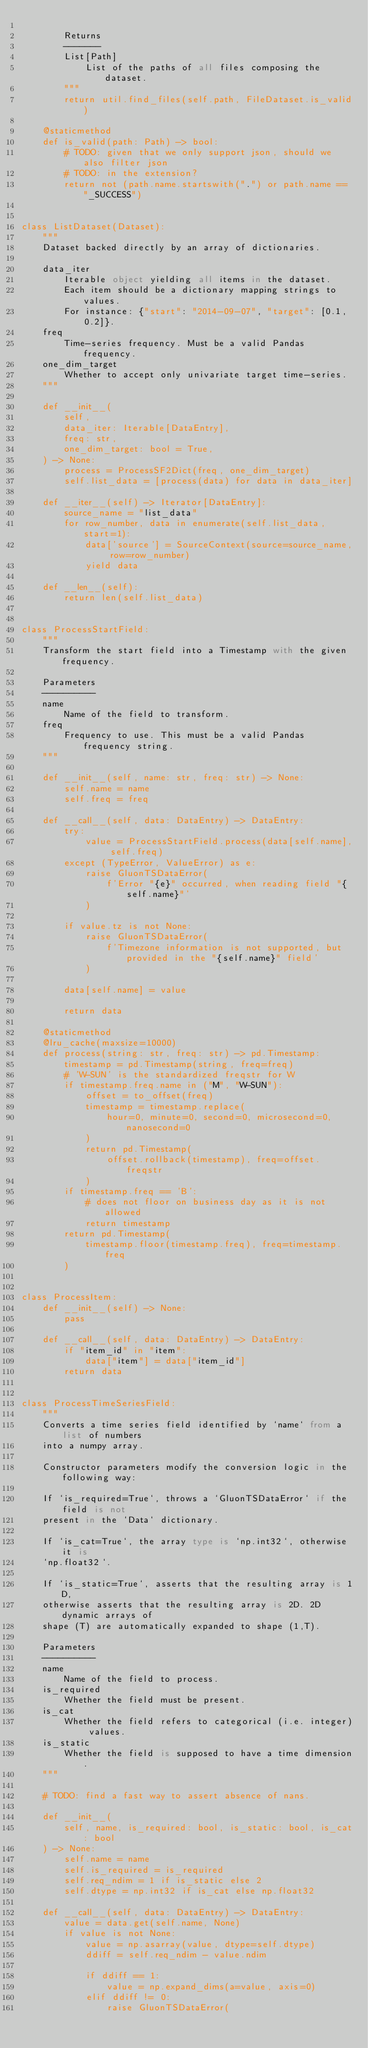<code> <loc_0><loc_0><loc_500><loc_500><_Python_>
        Returns
        -------
        List[Path]
            List of the paths of all files composing the dataset.
        """
        return util.find_files(self.path, FileDataset.is_valid)

    @staticmethod
    def is_valid(path: Path) -> bool:
        # TODO: given that we only support json, should we also filter json
        # TODO: in the extension?
        return not (path.name.startswith(".") or path.name == "_SUCCESS")


class ListDataset(Dataset):
    """
    Dataset backed directly by an array of dictionaries.

    data_iter
        Iterable object yielding all items in the dataset.
        Each item should be a dictionary mapping strings to values.
        For instance: {"start": "2014-09-07", "target": [0.1, 0.2]}.
    freq
        Time-series frequency. Must be a valid Pandas frequency.
    one_dim_target
        Whether to accept only univariate target time-series.
    """

    def __init__(
        self,
        data_iter: Iterable[DataEntry],
        freq: str,
        one_dim_target: bool = True,
    ) -> None:
        process = ProcessSF2Dict(freq, one_dim_target)
        self.list_data = [process(data) for data in data_iter]

    def __iter__(self) -> Iterator[DataEntry]:
        source_name = "list_data"
        for row_number, data in enumerate(self.list_data, start=1):
            data['source'] = SourceContext(source=source_name, row=row_number)
            yield data

    def __len__(self):
        return len(self.list_data)


class ProcessStartField:
    """
    Transform the start field into a Timestamp with the given frequency.

    Parameters
    ----------
    name
        Name of the field to transform.
    freq
        Frequency to use. This must be a valid Pandas frequency string.
    """

    def __init__(self, name: str, freq: str) -> None:
        self.name = name
        self.freq = freq

    def __call__(self, data: DataEntry) -> DataEntry:
        try:
            value = ProcessStartField.process(data[self.name], self.freq)
        except (TypeError, ValueError) as e:
            raise GluonTSDataError(
                f'Error "{e}" occurred, when reading field "{self.name}"'
            )

        if value.tz is not None:
            raise GluonTSDataError(
                f'Timezone information is not supported, but provided in the "{self.name}" field'
            )

        data[self.name] = value

        return data

    @staticmethod
    @lru_cache(maxsize=10000)
    def process(string: str, freq: str) -> pd.Timestamp:
        timestamp = pd.Timestamp(string, freq=freq)
        # 'W-SUN' is the standardized freqstr for W
        if timestamp.freq.name in ("M", "W-SUN"):
            offset = to_offset(freq)
            timestamp = timestamp.replace(
                hour=0, minute=0, second=0, microsecond=0, nanosecond=0
            )
            return pd.Timestamp(
                offset.rollback(timestamp), freq=offset.freqstr
            )
        if timestamp.freq == 'B':
            # does not floor on business day as it is not allowed
            return timestamp
        return pd.Timestamp(
            timestamp.floor(timestamp.freq), freq=timestamp.freq
        )


class ProcessItem:
    def __init__(self) -> None:
        pass

    def __call__(self, data: DataEntry) -> DataEntry:
        if "item_id" in "item":
            data["item"] = data["item_id"]
        return data


class ProcessTimeSeriesField:
    """
    Converts a time series field identified by `name` from a list of numbers
    into a numpy array.

    Constructor parameters modify the conversion logic in the following way:

    If `is_required=True`, throws a `GluonTSDataError` if the field is not
    present in the `Data` dictionary.

    If `is_cat=True`, the array type is `np.int32`, otherwise it is
    `np.float32`.

    If `is_static=True`, asserts that the resulting array is 1D,
    otherwise asserts that the resulting array is 2D. 2D dynamic arrays of
    shape (T) are automatically expanded to shape (1,T).

    Parameters
    ----------
    name
        Name of the field to process.
    is_required
        Whether the field must be present.
    is_cat
        Whether the field refers to categorical (i.e. integer) values.
    is_static
        Whether the field is supposed to have a time dimension.
    """

    # TODO: find a fast way to assert absence of nans.

    def __init__(
        self, name, is_required: bool, is_static: bool, is_cat: bool
    ) -> None:
        self.name = name
        self.is_required = is_required
        self.req_ndim = 1 if is_static else 2
        self.dtype = np.int32 if is_cat else np.float32

    def __call__(self, data: DataEntry) -> DataEntry:
        value = data.get(self.name, None)
        if value is not None:
            value = np.asarray(value, dtype=self.dtype)
            ddiff = self.req_ndim - value.ndim

            if ddiff == 1:
                value = np.expand_dims(a=value, axis=0)
            elif ddiff != 0:
                raise GluonTSDataError(</code> 